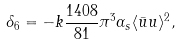Convert formula to latex. <formula><loc_0><loc_0><loc_500><loc_500>\delta _ { 6 } = - k \frac { 1 4 0 8 } { 8 1 } \pi ^ { 3 } \alpha _ { s } \langle \bar { u } u \rangle ^ { 2 } ,</formula> 